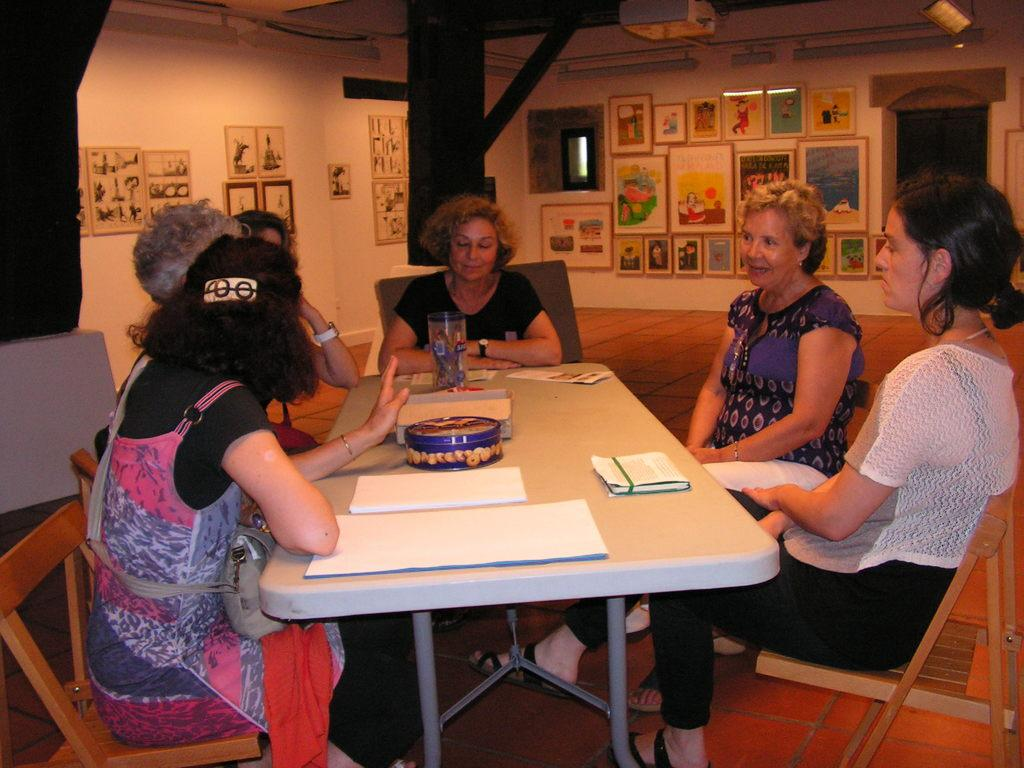What is on the wall in the image? There are pictures and posters on the wall. What are the women in the image doing? The women are sitting around a table. What objects can be seen on the table? There is a box, books, paper, and a container on the table. What type of pipe is being used by the women in the image? There is no pipe present in the image. What kind of amusement can be seen in the image? There is no amusement depicted in the image; it features women sitting around a table with various objects. 